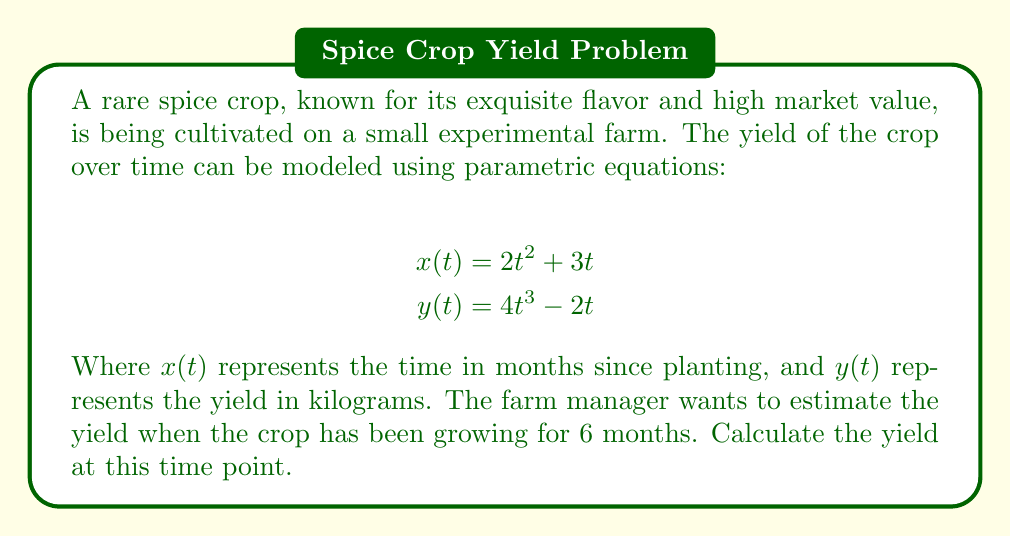Teach me how to tackle this problem. To solve this problem, we need to follow these steps:

1. Identify the given information:
   - $x(t) = 2t^2 + 3t$ (time in months)
   - $y(t) = 4t^3 - 2t$ (yield in kilograms)
   - We need to find the yield at 6 months

2. Find the value of $t$ when $x(t) = 6$:
   $$6 = 2t^2 + 3t$$

3. Solve this quadratic equation:
   $$2t^2 + 3t - 6 = 0$$
   
   Using the quadratic formula: $t = \frac{-b \pm \sqrt{b^2 - 4ac}}{2a}$
   
   $$t = \frac{-3 \pm \sqrt{3^2 - 4(2)(-6)}}{2(2)}$$
   $$t = \frac{-3 \pm \sqrt{9 + 48}}{4}$$
   $$t = \frac{-3 \pm \sqrt{57}}{4}$$

4. Since time cannot be negative, we take the positive root:
   $$t = \frac{-3 + \sqrt{57}}{4} \approx 1.3861$$

5. Now that we have $t$, we can calculate the yield $y(t)$:
   $$y(t) = 4t^3 - 2t$$
   $$y(1.3861) = 4(1.3861)^3 - 2(1.3861)$$
   $$y(1.3861) = 4(2.6632) - 2.7722$$
   $$y(1.3861) = 10.6528 - 2.7722$$
   $$y(1.3861) = 7.8806$$

Therefore, after 6 months, the estimated yield of the rare spice crop is approximately 7.8806 kilograms.
Answer: The estimated yield of the rare spice crop after 6 months is approximately 7.8806 kilograms. 